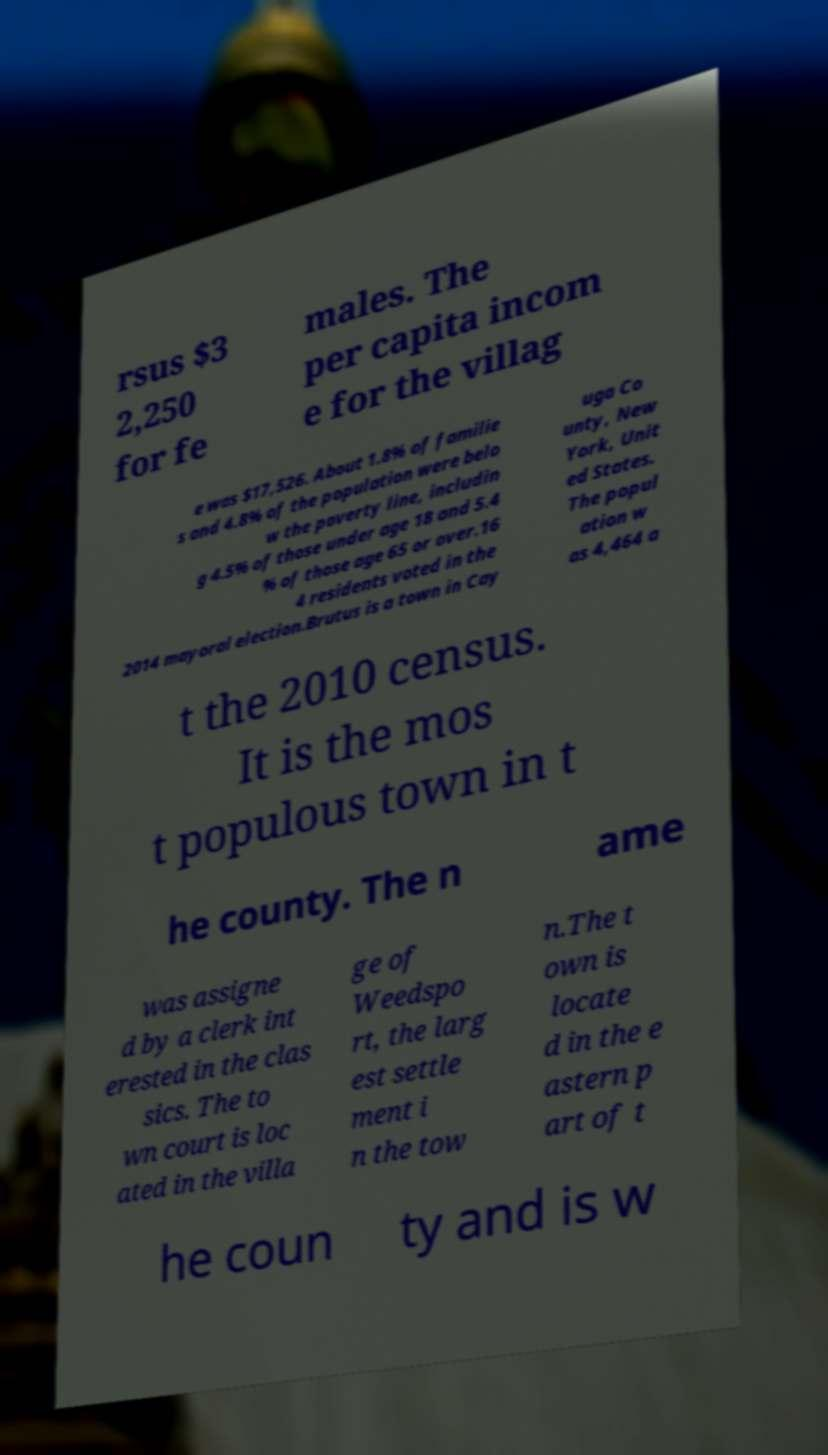Please identify and transcribe the text found in this image. rsus $3 2,250 for fe males. The per capita incom e for the villag e was $17,526. About 1.8% of familie s and 4.8% of the population were belo w the poverty line, includin g 4.5% of those under age 18 and 5.4 % of those age 65 or over.16 4 residents voted in the 2014 mayoral election.Brutus is a town in Cay uga Co unty, New York, Unit ed States. The popul ation w as 4,464 a t the 2010 census. It is the mos t populous town in t he county. The n ame was assigne d by a clerk int erested in the clas sics. The to wn court is loc ated in the villa ge of Weedspo rt, the larg est settle ment i n the tow n.The t own is locate d in the e astern p art of t he coun ty and is w 